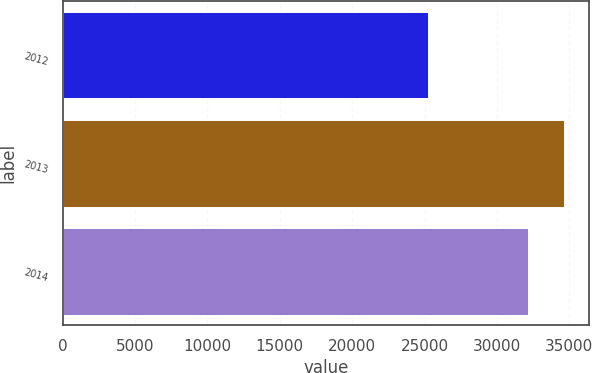<chart> <loc_0><loc_0><loc_500><loc_500><bar_chart><fcel>2012<fcel>2013<fcel>2014<nl><fcel>25209<fcel>34645<fcel>32141<nl></chart> 